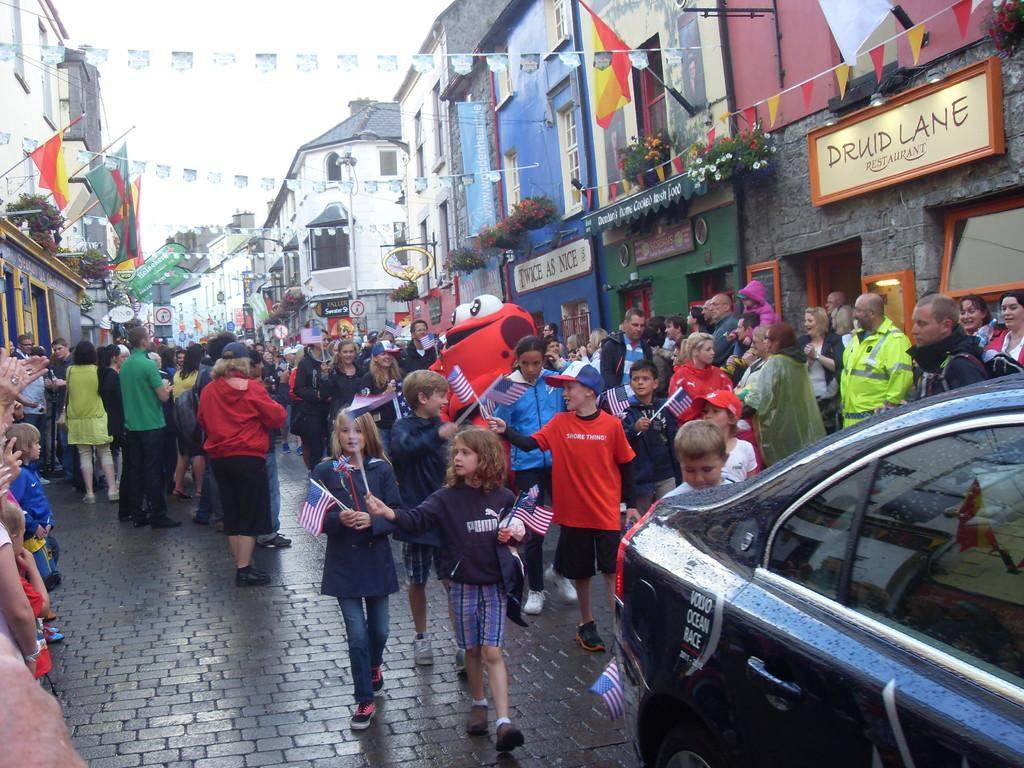What is the main subject of the image? The main subject of the image is a crowd. What are some people in the crowd doing? Some people in the crowd are holding flags. What else can be seen in the image besides the crowd? There is a car, buildings on the sides of the road, flags on the buildings, pots with plants on the buildings, and name boards on the buildings. What type of industry can be seen in the image? There is no specific industry depicted in the image; it primarily features a crowd, a car, and buildings with flags, pots with plants, and name boards. 